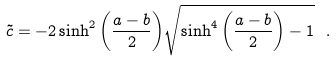Convert formula to latex. <formula><loc_0><loc_0><loc_500><loc_500>\tilde { c } = - 2 \sinh ^ { 2 } { \left ( \frac { a - b } { 2 } \right ) } \sqrt { \sinh ^ { 4 } { \left ( \frac { a - b } { 2 } \right ) } - 1 } \ .</formula> 